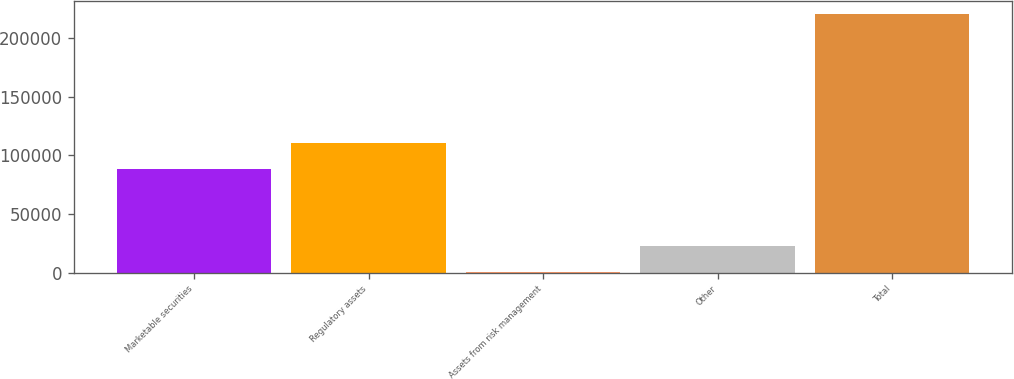Convert chart to OTSL. <chart><loc_0><loc_0><loc_500><loc_500><bar_chart><fcel>Marketable securities<fcel>Regulatory assets<fcel>Assets from risk management<fcel>Other<fcel>Total<nl><fcel>88409<fcel>110977<fcel>803<fcel>22786.3<fcel>220636<nl></chart> 